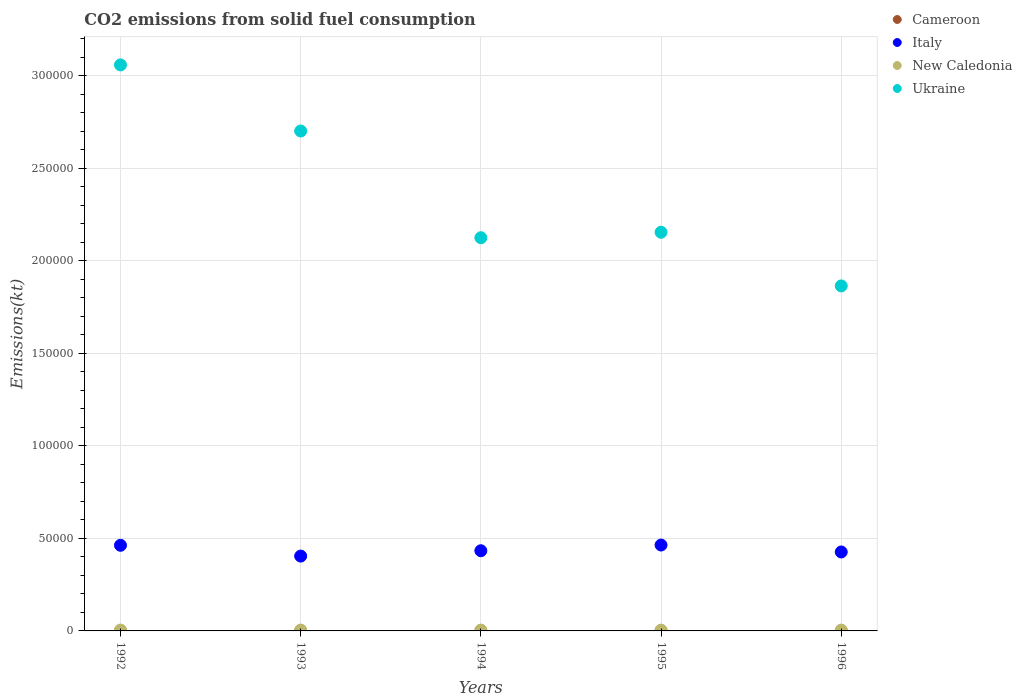How many different coloured dotlines are there?
Give a very brief answer. 4. What is the amount of CO2 emitted in Cameroon in 1992?
Provide a succinct answer. 3.67. Across all years, what is the maximum amount of CO2 emitted in New Caledonia?
Ensure brevity in your answer.  451.04. Across all years, what is the minimum amount of CO2 emitted in Cameroon?
Offer a terse response. 3.67. What is the total amount of CO2 emitted in New Caledonia in the graph?
Offer a very short reply. 2222.2. What is the difference between the amount of CO2 emitted in New Caledonia in 1992 and that in 1996?
Ensure brevity in your answer.  3.67. What is the difference between the amount of CO2 emitted in Italy in 1995 and the amount of CO2 emitted in New Caledonia in 1996?
Keep it short and to the point. 4.59e+04. What is the average amount of CO2 emitted in Cameroon per year?
Provide a succinct answer. 3.67. In the year 1996, what is the difference between the amount of CO2 emitted in Cameroon and amount of CO2 emitted in Ukraine?
Give a very brief answer. -1.86e+05. What is the ratio of the amount of CO2 emitted in Ukraine in 1993 to that in 1995?
Keep it short and to the point. 1.25. Is the difference between the amount of CO2 emitted in Cameroon in 1994 and 1995 greater than the difference between the amount of CO2 emitted in Ukraine in 1994 and 1995?
Offer a very short reply. Yes. What is the difference between the highest and the second highest amount of CO2 emitted in Italy?
Provide a succinct answer. 139.35. What is the difference between the highest and the lowest amount of CO2 emitted in Italy?
Your answer should be very brief. 5973.54. In how many years, is the amount of CO2 emitted in Ukraine greater than the average amount of CO2 emitted in Ukraine taken over all years?
Your response must be concise. 2. Is the sum of the amount of CO2 emitted in Italy in 1992 and 1995 greater than the maximum amount of CO2 emitted in New Caledonia across all years?
Your answer should be very brief. Yes. Is it the case that in every year, the sum of the amount of CO2 emitted in Italy and amount of CO2 emitted in New Caledonia  is greater than the sum of amount of CO2 emitted in Cameroon and amount of CO2 emitted in Ukraine?
Give a very brief answer. No. Is it the case that in every year, the sum of the amount of CO2 emitted in Italy and amount of CO2 emitted in Ukraine  is greater than the amount of CO2 emitted in New Caledonia?
Keep it short and to the point. Yes. Does the amount of CO2 emitted in Italy monotonically increase over the years?
Provide a short and direct response. No. Is the amount of CO2 emitted in Ukraine strictly greater than the amount of CO2 emitted in Italy over the years?
Give a very brief answer. Yes. Is the amount of CO2 emitted in New Caledonia strictly less than the amount of CO2 emitted in Italy over the years?
Your answer should be very brief. Yes. How many dotlines are there?
Give a very brief answer. 4. Does the graph contain grids?
Your answer should be very brief. Yes. Where does the legend appear in the graph?
Provide a short and direct response. Top right. How many legend labels are there?
Offer a very short reply. 4. What is the title of the graph?
Ensure brevity in your answer.  CO2 emissions from solid fuel consumption. What is the label or title of the X-axis?
Offer a terse response. Years. What is the label or title of the Y-axis?
Provide a short and direct response. Emissions(kt). What is the Emissions(kt) in Cameroon in 1992?
Keep it short and to the point. 3.67. What is the Emissions(kt) of Italy in 1992?
Your answer should be compact. 4.63e+04. What is the Emissions(kt) in New Caledonia in 1992?
Ensure brevity in your answer.  451.04. What is the Emissions(kt) of Ukraine in 1992?
Provide a succinct answer. 3.06e+05. What is the Emissions(kt) in Cameroon in 1993?
Keep it short and to the point. 3.67. What is the Emissions(kt) of Italy in 1993?
Keep it short and to the point. 4.04e+04. What is the Emissions(kt) of New Caledonia in 1993?
Offer a terse response. 451.04. What is the Emissions(kt) in Ukraine in 1993?
Ensure brevity in your answer.  2.70e+05. What is the Emissions(kt) in Cameroon in 1994?
Provide a succinct answer. 3.67. What is the Emissions(kt) of Italy in 1994?
Your response must be concise. 4.33e+04. What is the Emissions(kt) in New Caledonia in 1994?
Your answer should be very brief. 436.37. What is the Emissions(kt) of Ukraine in 1994?
Your answer should be compact. 2.12e+05. What is the Emissions(kt) in Cameroon in 1995?
Offer a terse response. 3.67. What is the Emissions(kt) of Italy in 1995?
Make the answer very short. 4.64e+04. What is the Emissions(kt) of New Caledonia in 1995?
Your response must be concise. 436.37. What is the Emissions(kt) of Ukraine in 1995?
Provide a short and direct response. 2.15e+05. What is the Emissions(kt) in Cameroon in 1996?
Provide a succinct answer. 3.67. What is the Emissions(kt) in Italy in 1996?
Offer a very short reply. 4.26e+04. What is the Emissions(kt) of New Caledonia in 1996?
Provide a short and direct response. 447.37. What is the Emissions(kt) of Ukraine in 1996?
Your response must be concise. 1.86e+05. Across all years, what is the maximum Emissions(kt) in Cameroon?
Provide a succinct answer. 3.67. Across all years, what is the maximum Emissions(kt) in Italy?
Give a very brief answer. 4.64e+04. Across all years, what is the maximum Emissions(kt) in New Caledonia?
Make the answer very short. 451.04. Across all years, what is the maximum Emissions(kt) in Ukraine?
Give a very brief answer. 3.06e+05. Across all years, what is the minimum Emissions(kt) in Cameroon?
Give a very brief answer. 3.67. Across all years, what is the minimum Emissions(kt) of Italy?
Ensure brevity in your answer.  4.04e+04. Across all years, what is the minimum Emissions(kt) in New Caledonia?
Your response must be concise. 436.37. Across all years, what is the minimum Emissions(kt) in Ukraine?
Ensure brevity in your answer.  1.86e+05. What is the total Emissions(kt) of Cameroon in the graph?
Keep it short and to the point. 18.34. What is the total Emissions(kt) of Italy in the graph?
Provide a succinct answer. 2.19e+05. What is the total Emissions(kt) of New Caledonia in the graph?
Keep it short and to the point. 2222.2. What is the total Emissions(kt) in Ukraine in the graph?
Ensure brevity in your answer.  1.19e+06. What is the difference between the Emissions(kt) of Cameroon in 1992 and that in 1993?
Provide a short and direct response. 0. What is the difference between the Emissions(kt) in Italy in 1992 and that in 1993?
Offer a very short reply. 5834.2. What is the difference between the Emissions(kt) in New Caledonia in 1992 and that in 1993?
Keep it short and to the point. 0. What is the difference between the Emissions(kt) of Ukraine in 1992 and that in 1993?
Your answer should be compact. 3.57e+04. What is the difference between the Emissions(kt) in Italy in 1992 and that in 1994?
Ensure brevity in your answer.  2944.6. What is the difference between the Emissions(kt) of New Caledonia in 1992 and that in 1994?
Provide a succinct answer. 14.67. What is the difference between the Emissions(kt) of Ukraine in 1992 and that in 1994?
Offer a terse response. 9.34e+04. What is the difference between the Emissions(kt) in Italy in 1992 and that in 1995?
Make the answer very short. -139.35. What is the difference between the Emissions(kt) in New Caledonia in 1992 and that in 1995?
Keep it short and to the point. 14.67. What is the difference between the Emissions(kt) in Ukraine in 1992 and that in 1995?
Provide a succinct answer. 9.04e+04. What is the difference between the Emissions(kt) in Italy in 1992 and that in 1996?
Provide a short and direct response. 3611.99. What is the difference between the Emissions(kt) of New Caledonia in 1992 and that in 1996?
Your answer should be very brief. 3.67. What is the difference between the Emissions(kt) of Ukraine in 1992 and that in 1996?
Keep it short and to the point. 1.19e+05. What is the difference between the Emissions(kt) in Italy in 1993 and that in 1994?
Make the answer very short. -2889.6. What is the difference between the Emissions(kt) in New Caledonia in 1993 and that in 1994?
Provide a succinct answer. 14.67. What is the difference between the Emissions(kt) of Ukraine in 1993 and that in 1994?
Give a very brief answer. 5.76e+04. What is the difference between the Emissions(kt) in Cameroon in 1993 and that in 1995?
Ensure brevity in your answer.  0. What is the difference between the Emissions(kt) in Italy in 1993 and that in 1995?
Your answer should be very brief. -5973.54. What is the difference between the Emissions(kt) of New Caledonia in 1993 and that in 1995?
Make the answer very short. 14.67. What is the difference between the Emissions(kt) of Ukraine in 1993 and that in 1995?
Provide a succinct answer. 5.47e+04. What is the difference between the Emissions(kt) of Italy in 1993 and that in 1996?
Keep it short and to the point. -2222.2. What is the difference between the Emissions(kt) of New Caledonia in 1993 and that in 1996?
Your answer should be compact. 3.67. What is the difference between the Emissions(kt) in Ukraine in 1993 and that in 1996?
Keep it short and to the point. 8.37e+04. What is the difference between the Emissions(kt) of Italy in 1994 and that in 1995?
Your response must be concise. -3083.95. What is the difference between the Emissions(kt) of Ukraine in 1994 and that in 1995?
Ensure brevity in your answer.  -2948.27. What is the difference between the Emissions(kt) of Cameroon in 1994 and that in 1996?
Keep it short and to the point. 0. What is the difference between the Emissions(kt) of Italy in 1994 and that in 1996?
Make the answer very short. 667.39. What is the difference between the Emissions(kt) in New Caledonia in 1994 and that in 1996?
Provide a succinct answer. -11. What is the difference between the Emissions(kt) of Ukraine in 1994 and that in 1996?
Keep it short and to the point. 2.60e+04. What is the difference between the Emissions(kt) of Italy in 1995 and that in 1996?
Your answer should be very brief. 3751.34. What is the difference between the Emissions(kt) in New Caledonia in 1995 and that in 1996?
Ensure brevity in your answer.  -11. What is the difference between the Emissions(kt) in Ukraine in 1995 and that in 1996?
Offer a terse response. 2.90e+04. What is the difference between the Emissions(kt) of Cameroon in 1992 and the Emissions(kt) of Italy in 1993?
Make the answer very short. -4.04e+04. What is the difference between the Emissions(kt) of Cameroon in 1992 and the Emissions(kt) of New Caledonia in 1993?
Provide a succinct answer. -447.37. What is the difference between the Emissions(kt) in Cameroon in 1992 and the Emissions(kt) in Ukraine in 1993?
Your answer should be compact. -2.70e+05. What is the difference between the Emissions(kt) in Italy in 1992 and the Emissions(kt) in New Caledonia in 1993?
Your response must be concise. 4.58e+04. What is the difference between the Emissions(kt) in Italy in 1992 and the Emissions(kt) in Ukraine in 1993?
Provide a succinct answer. -2.24e+05. What is the difference between the Emissions(kt) of New Caledonia in 1992 and the Emissions(kt) of Ukraine in 1993?
Keep it short and to the point. -2.70e+05. What is the difference between the Emissions(kt) in Cameroon in 1992 and the Emissions(kt) in Italy in 1994?
Your answer should be very brief. -4.33e+04. What is the difference between the Emissions(kt) of Cameroon in 1992 and the Emissions(kt) of New Caledonia in 1994?
Provide a succinct answer. -432.71. What is the difference between the Emissions(kt) of Cameroon in 1992 and the Emissions(kt) of Ukraine in 1994?
Keep it short and to the point. -2.12e+05. What is the difference between the Emissions(kt) of Italy in 1992 and the Emissions(kt) of New Caledonia in 1994?
Provide a short and direct response. 4.58e+04. What is the difference between the Emissions(kt) in Italy in 1992 and the Emissions(kt) in Ukraine in 1994?
Keep it short and to the point. -1.66e+05. What is the difference between the Emissions(kt) of New Caledonia in 1992 and the Emissions(kt) of Ukraine in 1994?
Keep it short and to the point. -2.12e+05. What is the difference between the Emissions(kt) in Cameroon in 1992 and the Emissions(kt) in Italy in 1995?
Your answer should be compact. -4.64e+04. What is the difference between the Emissions(kt) in Cameroon in 1992 and the Emissions(kt) in New Caledonia in 1995?
Provide a succinct answer. -432.71. What is the difference between the Emissions(kt) in Cameroon in 1992 and the Emissions(kt) in Ukraine in 1995?
Your response must be concise. -2.15e+05. What is the difference between the Emissions(kt) of Italy in 1992 and the Emissions(kt) of New Caledonia in 1995?
Provide a short and direct response. 4.58e+04. What is the difference between the Emissions(kt) in Italy in 1992 and the Emissions(kt) in Ukraine in 1995?
Ensure brevity in your answer.  -1.69e+05. What is the difference between the Emissions(kt) of New Caledonia in 1992 and the Emissions(kt) of Ukraine in 1995?
Offer a very short reply. -2.15e+05. What is the difference between the Emissions(kt) of Cameroon in 1992 and the Emissions(kt) of Italy in 1996?
Provide a succinct answer. -4.26e+04. What is the difference between the Emissions(kt) of Cameroon in 1992 and the Emissions(kt) of New Caledonia in 1996?
Provide a short and direct response. -443.71. What is the difference between the Emissions(kt) of Cameroon in 1992 and the Emissions(kt) of Ukraine in 1996?
Provide a succinct answer. -1.86e+05. What is the difference between the Emissions(kt) of Italy in 1992 and the Emissions(kt) of New Caledonia in 1996?
Your response must be concise. 4.58e+04. What is the difference between the Emissions(kt) of Italy in 1992 and the Emissions(kt) of Ukraine in 1996?
Provide a succinct answer. -1.40e+05. What is the difference between the Emissions(kt) of New Caledonia in 1992 and the Emissions(kt) of Ukraine in 1996?
Provide a short and direct response. -1.86e+05. What is the difference between the Emissions(kt) of Cameroon in 1993 and the Emissions(kt) of Italy in 1994?
Ensure brevity in your answer.  -4.33e+04. What is the difference between the Emissions(kt) in Cameroon in 1993 and the Emissions(kt) in New Caledonia in 1994?
Make the answer very short. -432.71. What is the difference between the Emissions(kt) in Cameroon in 1993 and the Emissions(kt) in Ukraine in 1994?
Your answer should be compact. -2.12e+05. What is the difference between the Emissions(kt) in Italy in 1993 and the Emissions(kt) in New Caledonia in 1994?
Offer a very short reply. 4.00e+04. What is the difference between the Emissions(kt) in Italy in 1993 and the Emissions(kt) in Ukraine in 1994?
Provide a short and direct response. -1.72e+05. What is the difference between the Emissions(kt) in New Caledonia in 1993 and the Emissions(kt) in Ukraine in 1994?
Give a very brief answer. -2.12e+05. What is the difference between the Emissions(kt) of Cameroon in 1993 and the Emissions(kt) of Italy in 1995?
Your answer should be compact. -4.64e+04. What is the difference between the Emissions(kt) of Cameroon in 1993 and the Emissions(kt) of New Caledonia in 1995?
Your answer should be compact. -432.71. What is the difference between the Emissions(kt) of Cameroon in 1993 and the Emissions(kt) of Ukraine in 1995?
Your answer should be compact. -2.15e+05. What is the difference between the Emissions(kt) of Italy in 1993 and the Emissions(kt) of New Caledonia in 1995?
Your answer should be compact. 4.00e+04. What is the difference between the Emissions(kt) in Italy in 1993 and the Emissions(kt) in Ukraine in 1995?
Your answer should be very brief. -1.75e+05. What is the difference between the Emissions(kt) in New Caledonia in 1993 and the Emissions(kt) in Ukraine in 1995?
Your answer should be compact. -2.15e+05. What is the difference between the Emissions(kt) of Cameroon in 1993 and the Emissions(kt) of Italy in 1996?
Your answer should be very brief. -4.26e+04. What is the difference between the Emissions(kt) of Cameroon in 1993 and the Emissions(kt) of New Caledonia in 1996?
Provide a short and direct response. -443.71. What is the difference between the Emissions(kt) in Cameroon in 1993 and the Emissions(kt) in Ukraine in 1996?
Your answer should be compact. -1.86e+05. What is the difference between the Emissions(kt) in Italy in 1993 and the Emissions(kt) in New Caledonia in 1996?
Your answer should be very brief. 4.00e+04. What is the difference between the Emissions(kt) in Italy in 1993 and the Emissions(kt) in Ukraine in 1996?
Give a very brief answer. -1.46e+05. What is the difference between the Emissions(kt) of New Caledonia in 1993 and the Emissions(kt) of Ukraine in 1996?
Your answer should be very brief. -1.86e+05. What is the difference between the Emissions(kt) of Cameroon in 1994 and the Emissions(kt) of Italy in 1995?
Give a very brief answer. -4.64e+04. What is the difference between the Emissions(kt) in Cameroon in 1994 and the Emissions(kt) in New Caledonia in 1995?
Your response must be concise. -432.71. What is the difference between the Emissions(kt) in Cameroon in 1994 and the Emissions(kt) in Ukraine in 1995?
Make the answer very short. -2.15e+05. What is the difference between the Emissions(kt) of Italy in 1994 and the Emissions(kt) of New Caledonia in 1995?
Provide a short and direct response. 4.29e+04. What is the difference between the Emissions(kt) of Italy in 1994 and the Emissions(kt) of Ukraine in 1995?
Ensure brevity in your answer.  -1.72e+05. What is the difference between the Emissions(kt) of New Caledonia in 1994 and the Emissions(kt) of Ukraine in 1995?
Make the answer very short. -2.15e+05. What is the difference between the Emissions(kt) in Cameroon in 1994 and the Emissions(kt) in Italy in 1996?
Your answer should be very brief. -4.26e+04. What is the difference between the Emissions(kt) in Cameroon in 1994 and the Emissions(kt) in New Caledonia in 1996?
Ensure brevity in your answer.  -443.71. What is the difference between the Emissions(kt) in Cameroon in 1994 and the Emissions(kt) in Ukraine in 1996?
Ensure brevity in your answer.  -1.86e+05. What is the difference between the Emissions(kt) in Italy in 1994 and the Emissions(kt) in New Caledonia in 1996?
Make the answer very short. 4.29e+04. What is the difference between the Emissions(kt) in Italy in 1994 and the Emissions(kt) in Ukraine in 1996?
Give a very brief answer. -1.43e+05. What is the difference between the Emissions(kt) of New Caledonia in 1994 and the Emissions(kt) of Ukraine in 1996?
Make the answer very short. -1.86e+05. What is the difference between the Emissions(kt) of Cameroon in 1995 and the Emissions(kt) of Italy in 1996?
Keep it short and to the point. -4.26e+04. What is the difference between the Emissions(kt) of Cameroon in 1995 and the Emissions(kt) of New Caledonia in 1996?
Offer a terse response. -443.71. What is the difference between the Emissions(kt) of Cameroon in 1995 and the Emissions(kt) of Ukraine in 1996?
Keep it short and to the point. -1.86e+05. What is the difference between the Emissions(kt) of Italy in 1995 and the Emissions(kt) of New Caledonia in 1996?
Your answer should be compact. 4.59e+04. What is the difference between the Emissions(kt) of Italy in 1995 and the Emissions(kt) of Ukraine in 1996?
Your answer should be compact. -1.40e+05. What is the difference between the Emissions(kt) in New Caledonia in 1995 and the Emissions(kt) in Ukraine in 1996?
Ensure brevity in your answer.  -1.86e+05. What is the average Emissions(kt) in Cameroon per year?
Offer a very short reply. 3.67. What is the average Emissions(kt) of Italy per year?
Ensure brevity in your answer.  4.38e+04. What is the average Emissions(kt) in New Caledonia per year?
Keep it short and to the point. 444.44. What is the average Emissions(kt) in Ukraine per year?
Offer a terse response. 2.38e+05. In the year 1992, what is the difference between the Emissions(kt) of Cameroon and Emissions(kt) of Italy?
Your response must be concise. -4.63e+04. In the year 1992, what is the difference between the Emissions(kt) in Cameroon and Emissions(kt) in New Caledonia?
Give a very brief answer. -447.37. In the year 1992, what is the difference between the Emissions(kt) of Cameroon and Emissions(kt) of Ukraine?
Provide a succinct answer. -3.06e+05. In the year 1992, what is the difference between the Emissions(kt) of Italy and Emissions(kt) of New Caledonia?
Give a very brief answer. 4.58e+04. In the year 1992, what is the difference between the Emissions(kt) of Italy and Emissions(kt) of Ukraine?
Keep it short and to the point. -2.60e+05. In the year 1992, what is the difference between the Emissions(kt) in New Caledonia and Emissions(kt) in Ukraine?
Ensure brevity in your answer.  -3.05e+05. In the year 1993, what is the difference between the Emissions(kt) in Cameroon and Emissions(kt) in Italy?
Provide a short and direct response. -4.04e+04. In the year 1993, what is the difference between the Emissions(kt) in Cameroon and Emissions(kt) in New Caledonia?
Give a very brief answer. -447.37. In the year 1993, what is the difference between the Emissions(kt) of Cameroon and Emissions(kt) of Ukraine?
Offer a terse response. -2.70e+05. In the year 1993, what is the difference between the Emissions(kt) in Italy and Emissions(kt) in New Caledonia?
Offer a terse response. 4.00e+04. In the year 1993, what is the difference between the Emissions(kt) in Italy and Emissions(kt) in Ukraine?
Provide a short and direct response. -2.30e+05. In the year 1993, what is the difference between the Emissions(kt) of New Caledonia and Emissions(kt) of Ukraine?
Your answer should be very brief. -2.70e+05. In the year 1994, what is the difference between the Emissions(kt) of Cameroon and Emissions(kt) of Italy?
Your answer should be compact. -4.33e+04. In the year 1994, what is the difference between the Emissions(kt) in Cameroon and Emissions(kt) in New Caledonia?
Your answer should be very brief. -432.71. In the year 1994, what is the difference between the Emissions(kt) of Cameroon and Emissions(kt) of Ukraine?
Ensure brevity in your answer.  -2.12e+05. In the year 1994, what is the difference between the Emissions(kt) in Italy and Emissions(kt) in New Caledonia?
Provide a short and direct response. 4.29e+04. In the year 1994, what is the difference between the Emissions(kt) in Italy and Emissions(kt) in Ukraine?
Give a very brief answer. -1.69e+05. In the year 1994, what is the difference between the Emissions(kt) in New Caledonia and Emissions(kt) in Ukraine?
Keep it short and to the point. -2.12e+05. In the year 1995, what is the difference between the Emissions(kt) in Cameroon and Emissions(kt) in Italy?
Keep it short and to the point. -4.64e+04. In the year 1995, what is the difference between the Emissions(kt) of Cameroon and Emissions(kt) of New Caledonia?
Keep it short and to the point. -432.71. In the year 1995, what is the difference between the Emissions(kt) of Cameroon and Emissions(kt) of Ukraine?
Your response must be concise. -2.15e+05. In the year 1995, what is the difference between the Emissions(kt) of Italy and Emissions(kt) of New Caledonia?
Offer a very short reply. 4.60e+04. In the year 1995, what is the difference between the Emissions(kt) in Italy and Emissions(kt) in Ukraine?
Keep it short and to the point. -1.69e+05. In the year 1995, what is the difference between the Emissions(kt) of New Caledonia and Emissions(kt) of Ukraine?
Offer a terse response. -2.15e+05. In the year 1996, what is the difference between the Emissions(kt) in Cameroon and Emissions(kt) in Italy?
Give a very brief answer. -4.26e+04. In the year 1996, what is the difference between the Emissions(kt) in Cameroon and Emissions(kt) in New Caledonia?
Give a very brief answer. -443.71. In the year 1996, what is the difference between the Emissions(kt) in Cameroon and Emissions(kt) in Ukraine?
Offer a terse response. -1.86e+05. In the year 1996, what is the difference between the Emissions(kt) in Italy and Emissions(kt) in New Caledonia?
Keep it short and to the point. 4.22e+04. In the year 1996, what is the difference between the Emissions(kt) in Italy and Emissions(kt) in Ukraine?
Give a very brief answer. -1.44e+05. In the year 1996, what is the difference between the Emissions(kt) of New Caledonia and Emissions(kt) of Ukraine?
Make the answer very short. -1.86e+05. What is the ratio of the Emissions(kt) in Italy in 1992 to that in 1993?
Make the answer very short. 1.14. What is the ratio of the Emissions(kt) of New Caledonia in 1992 to that in 1993?
Give a very brief answer. 1. What is the ratio of the Emissions(kt) of Ukraine in 1992 to that in 1993?
Your answer should be compact. 1.13. What is the ratio of the Emissions(kt) in Italy in 1992 to that in 1994?
Your response must be concise. 1.07. What is the ratio of the Emissions(kt) of New Caledonia in 1992 to that in 1994?
Offer a terse response. 1.03. What is the ratio of the Emissions(kt) of Ukraine in 1992 to that in 1994?
Offer a terse response. 1.44. What is the ratio of the Emissions(kt) in Cameroon in 1992 to that in 1995?
Your answer should be compact. 1. What is the ratio of the Emissions(kt) of Italy in 1992 to that in 1995?
Give a very brief answer. 1. What is the ratio of the Emissions(kt) in New Caledonia in 1992 to that in 1995?
Keep it short and to the point. 1.03. What is the ratio of the Emissions(kt) in Ukraine in 1992 to that in 1995?
Provide a short and direct response. 1.42. What is the ratio of the Emissions(kt) of Italy in 1992 to that in 1996?
Your answer should be very brief. 1.08. What is the ratio of the Emissions(kt) of New Caledonia in 1992 to that in 1996?
Offer a terse response. 1.01. What is the ratio of the Emissions(kt) in Ukraine in 1992 to that in 1996?
Offer a very short reply. 1.64. What is the ratio of the Emissions(kt) in Cameroon in 1993 to that in 1994?
Your response must be concise. 1. What is the ratio of the Emissions(kt) in New Caledonia in 1993 to that in 1994?
Keep it short and to the point. 1.03. What is the ratio of the Emissions(kt) of Ukraine in 1993 to that in 1994?
Offer a terse response. 1.27. What is the ratio of the Emissions(kt) in Cameroon in 1993 to that in 1995?
Your response must be concise. 1. What is the ratio of the Emissions(kt) in Italy in 1993 to that in 1995?
Give a very brief answer. 0.87. What is the ratio of the Emissions(kt) of New Caledonia in 1993 to that in 1995?
Provide a succinct answer. 1.03. What is the ratio of the Emissions(kt) of Ukraine in 1993 to that in 1995?
Offer a very short reply. 1.25. What is the ratio of the Emissions(kt) of Cameroon in 1993 to that in 1996?
Offer a terse response. 1. What is the ratio of the Emissions(kt) in Italy in 1993 to that in 1996?
Your answer should be very brief. 0.95. What is the ratio of the Emissions(kt) in New Caledonia in 1993 to that in 1996?
Keep it short and to the point. 1.01. What is the ratio of the Emissions(kt) of Ukraine in 1993 to that in 1996?
Keep it short and to the point. 1.45. What is the ratio of the Emissions(kt) of Italy in 1994 to that in 1995?
Make the answer very short. 0.93. What is the ratio of the Emissions(kt) in Ukraine in 1994 to that in 1995?
Your answer should be very brief. 0.99. What is the ratio of the Emissions(kt) in Cameroon in 1994 to that in 1996?
Give a very brief answer. 1. What is the ratio of the Emissions(kt) in Italy in 1994 to that in 1996?
Offer a very short reply. 1.02. What is the ratio of the Emissions(kt) in New Caledonia in 1994 to that in 1996?
Give a very brief answer. 0.98. What is the ratio of the Emissions(kt) of Ukraine in 1994 to that in 1996?
Give a very brief answer. 1.14. What is the ratio of the Emissions(kt) of Cameroon in 1995 to that in 1996?
Your answer should be very brief. 1. What is the ratio of the Emissions(kt) in Italy in 1995 to that in 1996?
Offer a terse response. 1.09. What is the ratio of the Emissions(kt) of New Caledonia in 1995 to that in 1996?
Your response must be concise. 0.98. What is the ratio of the Emissions(kt) of Ukraine in 1995 to that in 1996?
Keep it short and to the point. 1.16. What is the difference between the highest and the second highest Emissions(kt) in Cameroon?
Your answer should be very brief. 0. What is the difference between the highest and the second highest Emissions(kt) of Italy?
Your answer should be very brief. 139.35. What is the difference between the highest and the second highest Emissions(kt) in Ukraine?
Ensure brevity in your answer.  3.57e+04. What is the difference between the highest and the lowest Emissions(kt) of Cameroon?
Your answer should be compact. 0. What is the difference between the highest and the lowest Emissions(kt) in Italy?
Provide a succinct answer. 5973.54. What is the difference between the highest and the lowest Emissions(kt) of New Caledonia?
Provide a succinct answer. 14.67. What is the difference between the highest and the lowest Emissions(kt) in Ukraine?
Keep it short and to the point. 1.19e+05. 